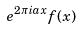<formula> <loc_0><loc_0><loc_500><loc_500>e ^ { 2 \pi i a x } f ( x )</formula> 